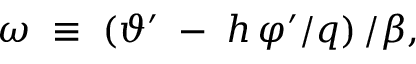<formula> <loc_0><loc_0><loc_500><loc_500>\omega \, \equiv \, \left ( \vartheta ^ { \prime } \, - \, h \, \varphi ^ { \prime } / q \right ) / \beta ,</formula> 